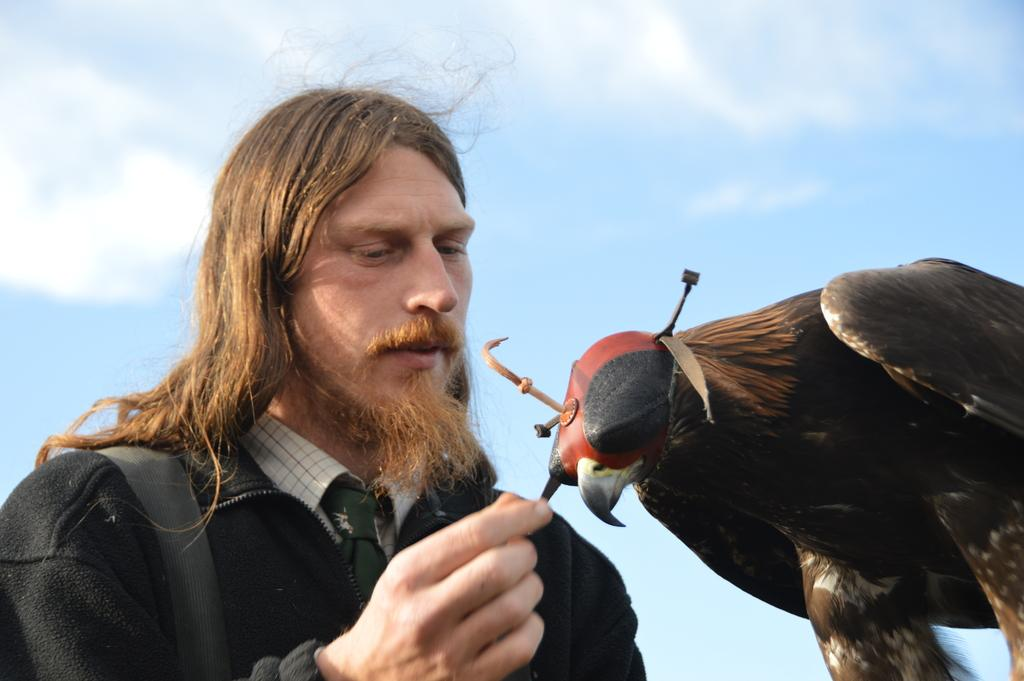Who or what is the main subject in the image? There is a man in the image. What other living creature is present in the image? There is a bird in the image. What can be seen in the background of the image? The sky is visible in the background of the image. What is the condition of the sky in the image? There are clouds in the sky. What type of poison is the bird using to attack the man in the image? There is no indication in the image that the bird is attacking the man or using any poison. 